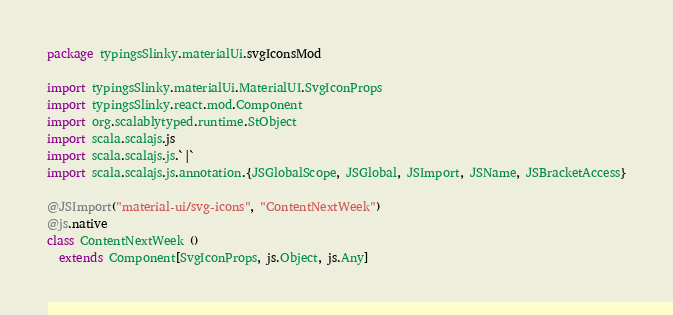Convert code to text. <code><loc_0><loc_0><loc_500><loc_500><_Scala_>package typingsSlinky.materialUi.svgIconsMod

import typingsSlinky.materialUi.MaterialUI.SvgIconProps
import typingsSlinky.react.mod.Component
import org.scalablytyped.runtime.StObject
import scala.scalajs.js
import scala.scalajs.js.`|`
import scala.scalajs.js.annotation.{JSGlobalScope, JSGlobal, JSImport, JSName, JSBracketAccess}

@JSImport("material-ui/svg-icons", "ContentNextWeek")
@js.native
class ContentNextWeek ()
  extends Component[SvgIconProps, js.Object, js.Any]
</code> 